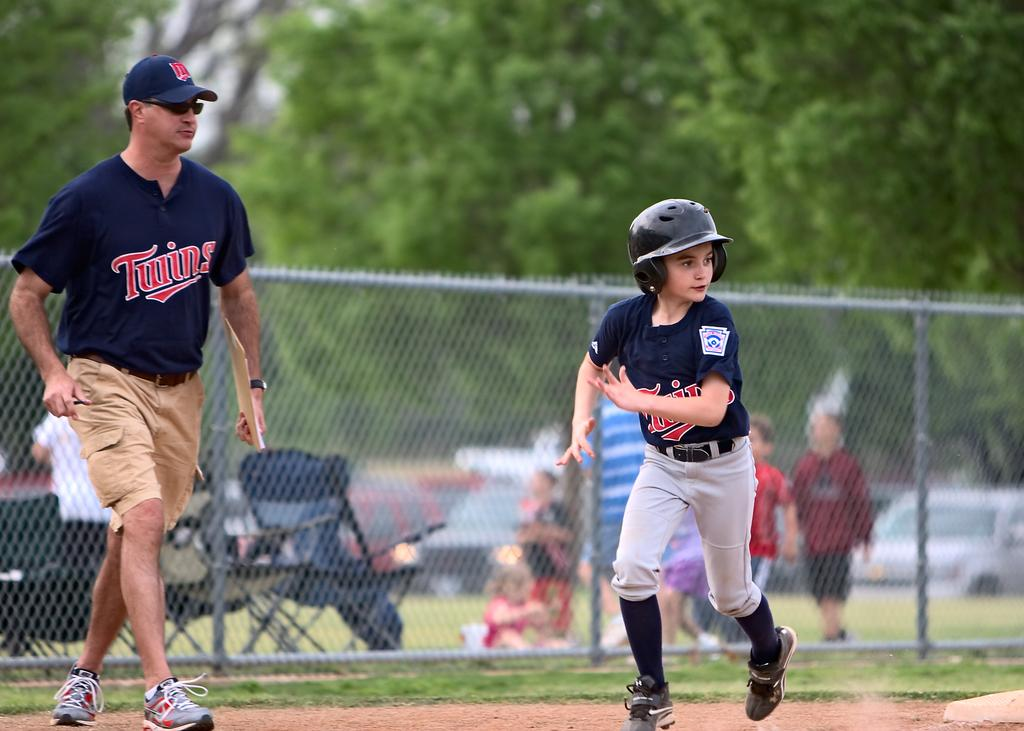Provide a one-sentence caption for the provided image. A boy running bases while a man in a Twins shirt looks on. 